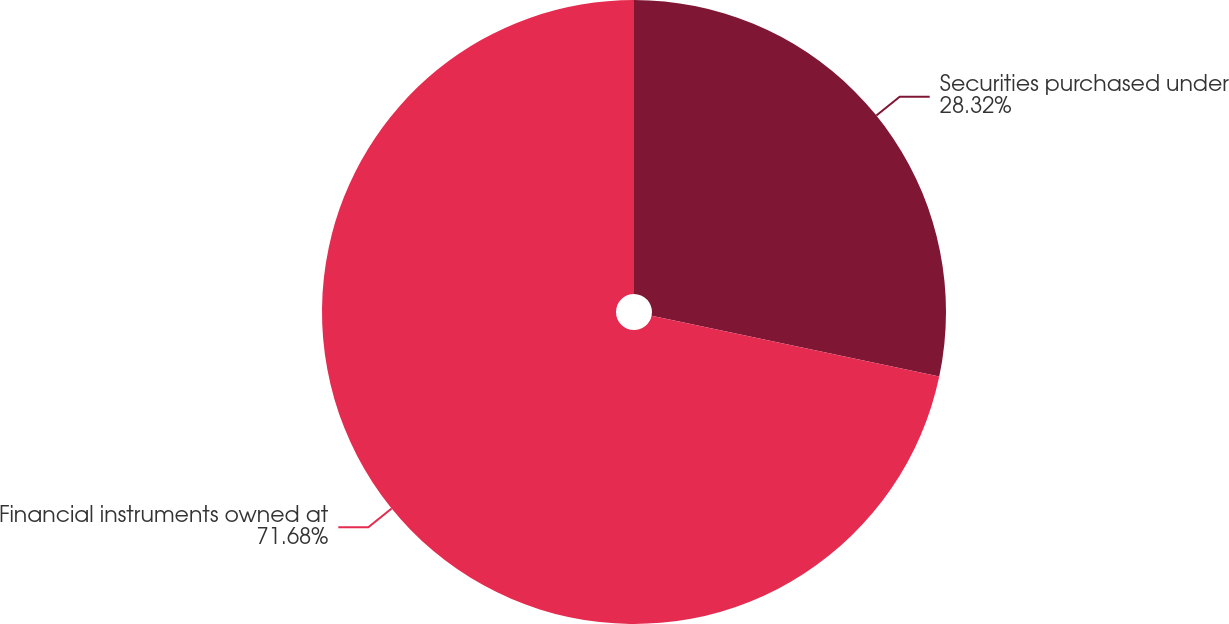<chart> <loc_0><loc_0><loc_500><loc_500><pie_chart><fcel>Securities purchased under<fcel>Financial instruments owned at<nl><fcel>28.32%<fcel>71.68%<nl></chart> 